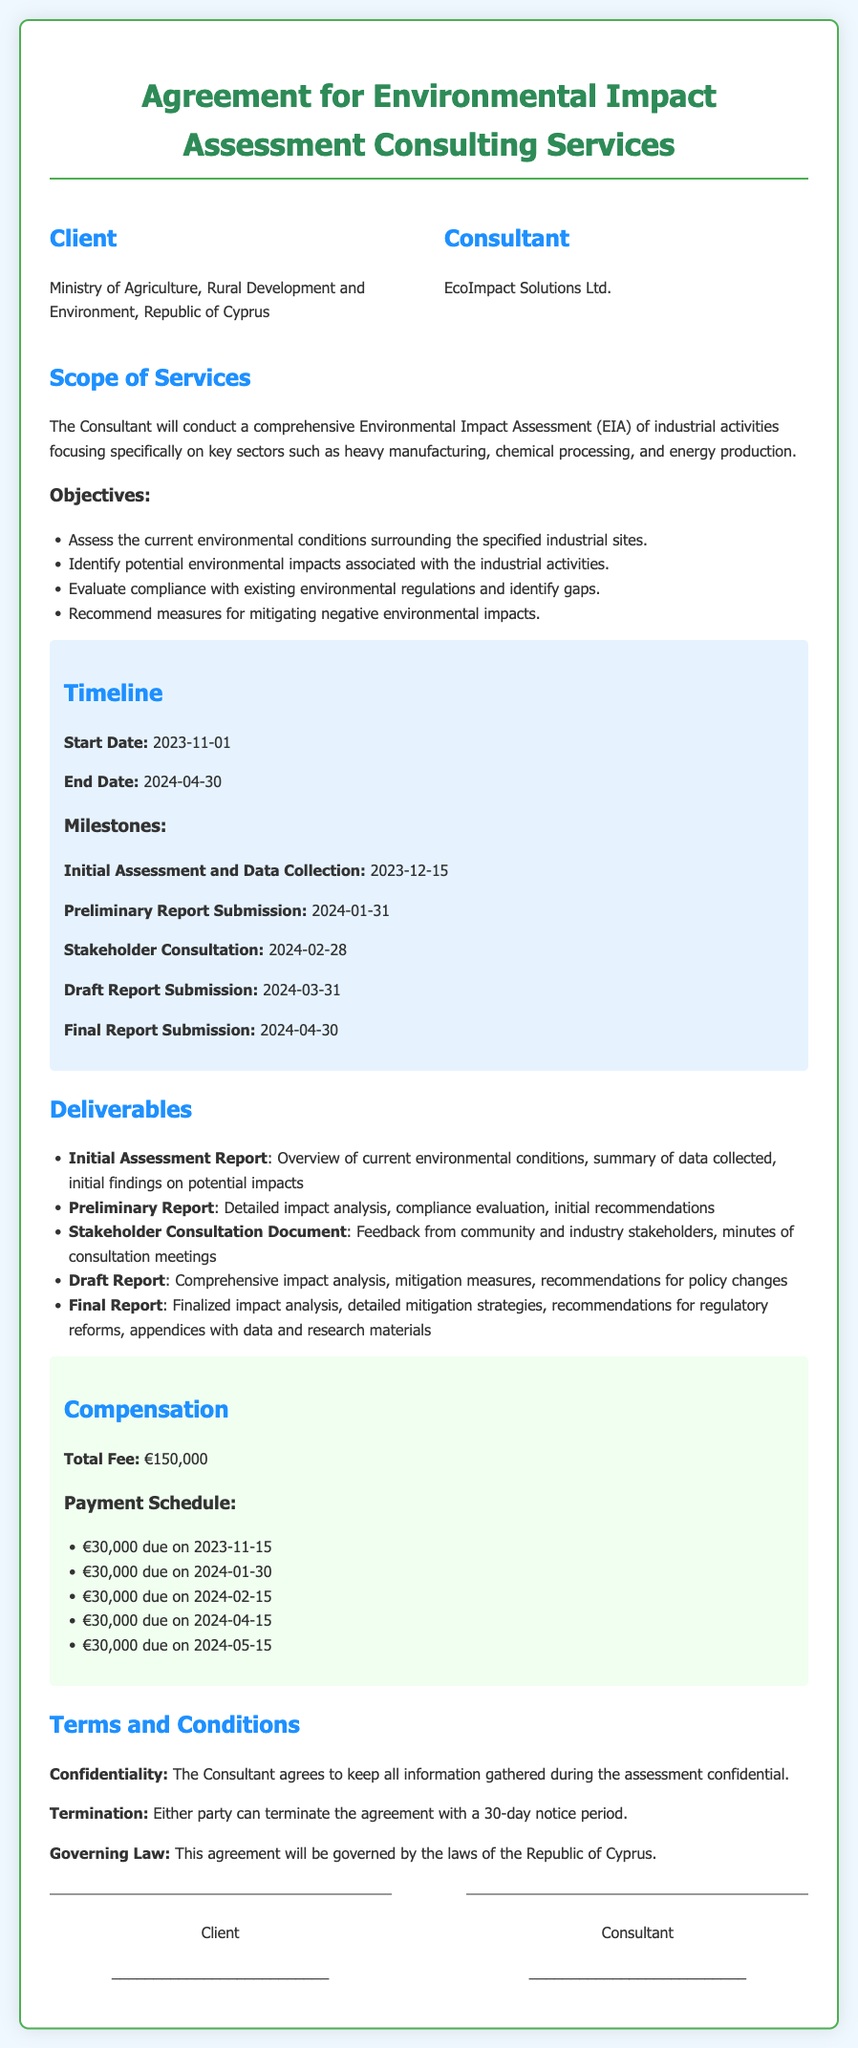what is the total fee for the consulting services? The total fee is stated in the compensation section of the document.
Answer: €150,000 who is the consultant providing the services? The consultant's name is mentioned at the beginning of the document.
Answer: EcoImpact Solutions Ltd when is the final report due? The due date for the final report is specified in the timeline section.
Answer: 2024-04-30 what is one objective of the Environmental Impact Assessment? The objectives can be found under the scope of services.
Answer: Assess the current environmental conditions how many payments are scheduled for the consulting services? The payment schedule lists the number of payment installments due.
Answer: 5 what is the governing law for this agreement? The governing law is specified in the terms and conditions section.
Answer: Republic of Cyprus which milestone occurs after the stakeholder consultation? The timeline mentions the sequence of milestones in order.
Answer: Draft Report Submission what is included in the Final Report deliverable? The deliverables section details what is included in the final report.
Answer: Finalized impact analysis, detailed mitigation strategies, recommendations for regulatory reforms, appendices with data and research materials 